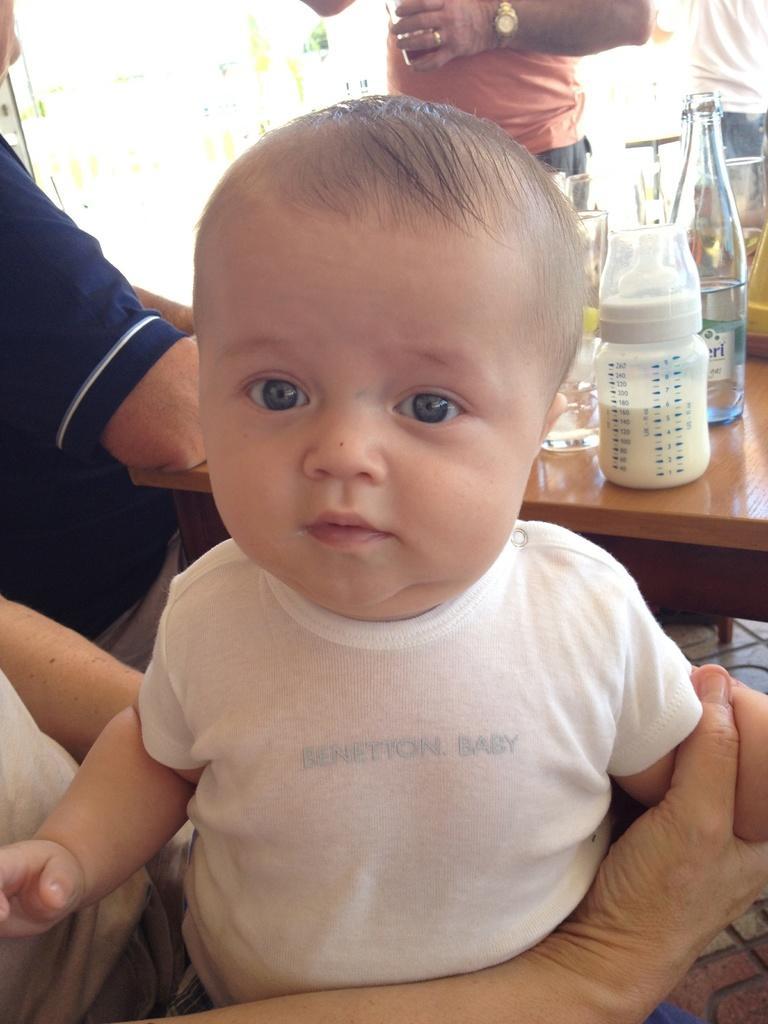Describe this image in one or two sentences. In this image I can see few people. Here on this table I can see a glass bottle and a milk bottle. 